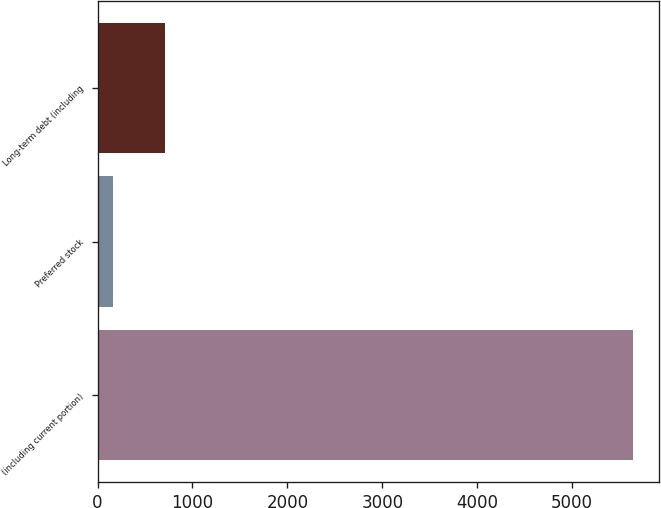<chart> <loc_0><loc_0><loc_500><loc_500><bar_chart><fcel>(including current portion)<fcel>Preferred stock<fcel>Long-term debt (including<nl><fcel>5636<fcel>162<fcel>709.4<nl></chart> 